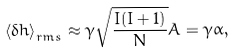Convert formula to latex. <formula><loc_0><loc_0><loc_500><loc_500>\left \langle \delta h \right \rangle _ { r m s } \approx \gamma \sqrt { \frac { I ( I + 1 ) } { N } } A = \gamma \alpha ,</formula> 